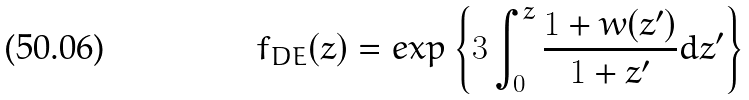<formula> <loc_0><loc_0><loc_500><loc_500>f _ { D E } ( z ) = e x p \left \{ 3 \int _ { 0 } ^ { z } \frac { 1 + w ( z ^ { \prime } ) } { 1 + z ^ { \prime } } d z ^ { \prime } \right \}</formula> 